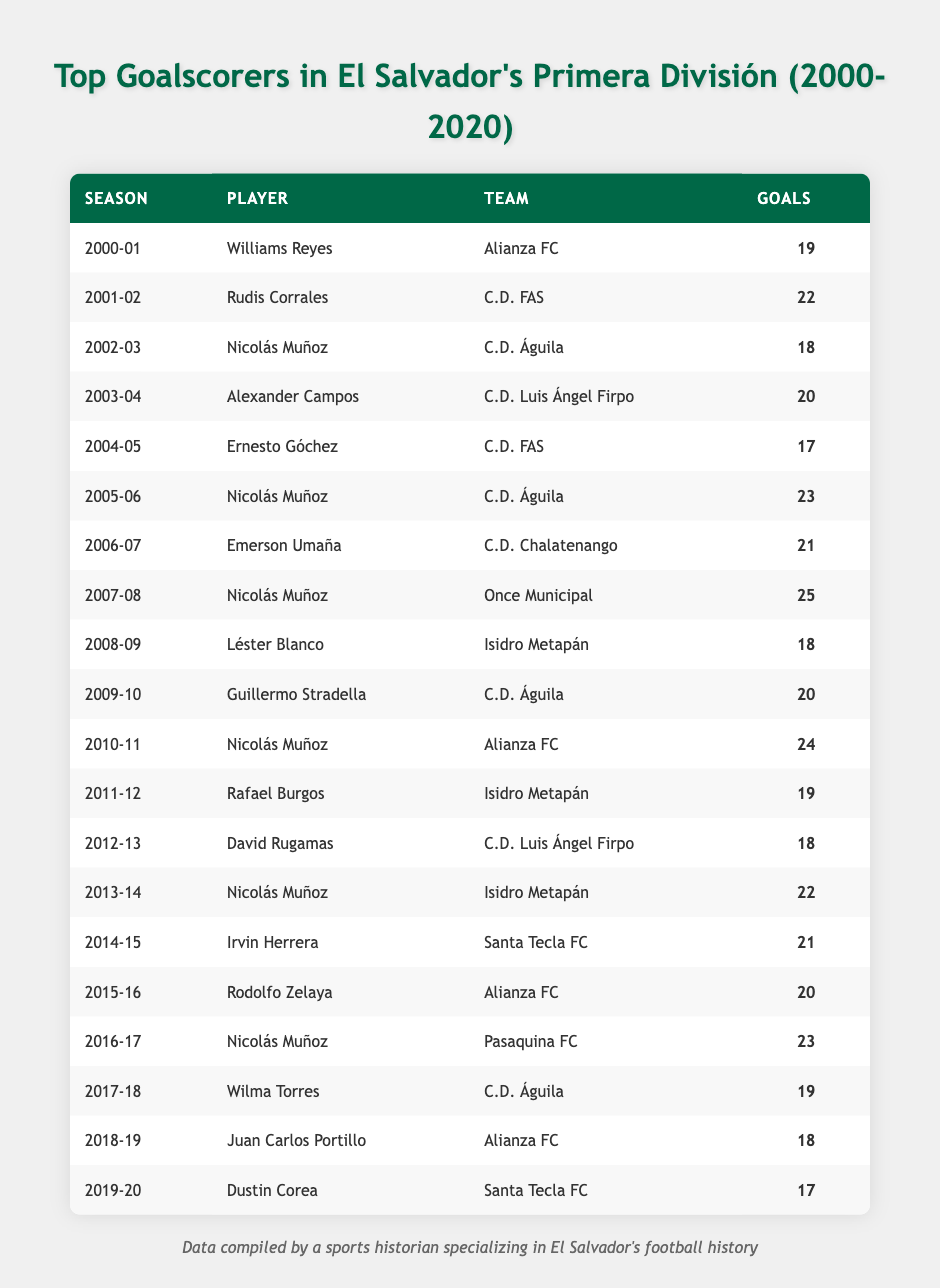What is the highest number of goals scored by a player in a single season? Looking at the table, we can see the goals scored by each player in each season. The highest number is 25 goals scored by Nicolás Muñoz in the 2007-08 season.
Answer: 25 Who was the top goal scorer in the 2010-11 season? The table identifies Nicolás Muñoz as the player with the highest goals in the 2010-11 season, scoring a total of 24 goals for Alianza FC.
Answer: Nicolás Muñoz Which team had the top scorer in the most seasons? Counting the seasons in which players from each team were the top scorers, Alianza FC appears three times (Williams Reyes in 2000-01, Nicolás Muñoz in 2010-11, and Rodolfo Zelaya in 2015-16).
Answer: Alianza FC What was the average number of goals scored by Nicolás Muñoz across all seasons he played in the table? Nicolás Muñoz had three seasons listed: 18 goals (2002-03), 23 goals (2005-06), 25 goals (2007-08), 24 goals (2010-11), and 22 goals (2013-14), which totals 112 goals over 5 seasons. To find the average, we calculate: 112/5 = 22.4.
Answer: 22.4 Was there any season where the top scorer scored less than 20 goals? Upon examining the table, there are several instances where the top scorer recorded fewer than 20 goals: Ernesto Góchez in 2004-05 (17 goals) and Dustin Corea in 2019-20 (17 goals).
Answer: Yes How many goals did the top scorers in the 2000-01 and 2019-20 seasons score combined? The top scorer for the 2000-01 season was Williams Reyes with 19 goals, and for the 2019-20 season, Dustin Corea scored 17 goals. Adding these together gives us 19 + 17 = 36.
Answer: 36 Which player scored the most goals in consecutive seasons? Nicolás Muñoz had a remarkable scoring streak with the following goals in consecutive seasons: 23 (2005-06), 25 (2007-08), and 24 (2010-11). His lowest consecutive tally was 18 in 2002-03 which breaks the sequence, so his highest consecutive total is 25 in 2007-08 itself.
Answer: 25 How many players scored less than 20 goals or equal in the 2004-05 season? In the 2004-05 season, Ernesto Góchez scored 17 goals, which is the only entry for that season; therefore, he is the only player scoring 20 or fewer goals.
Answer: 1 Which seasons did C.D. FAS contribute the top scorer? By reviewing the table, C.D. FAS had top scorers in two seasons: Rudis Corrales in 2001-02 with 22 goals and Ernesto Góchez in 2004-05 with 17 goals.
Answer: 2001-02 and 2004-05 